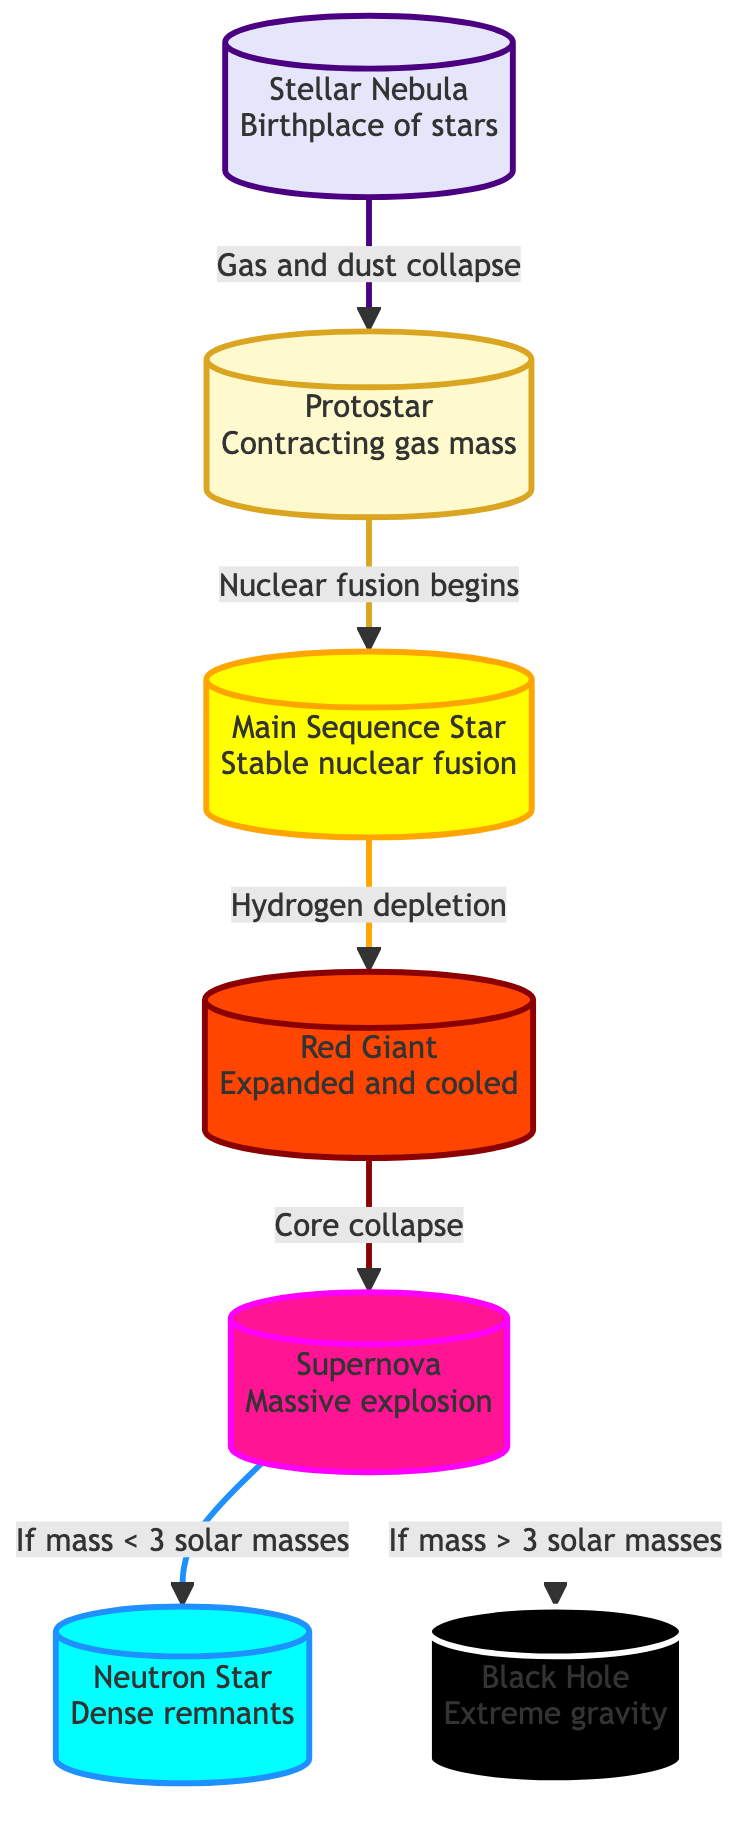What is the first stage of a star's lifecycle? The diagram indicates that the first stage is the "Stellar Nebula," which is identified at the top of the flowchart.
Answer: Stellar Nebula How many stages are shown in the star lifecycle? By counting the nodes in the diagram, we identify a total of 7 distinct stages: Stellar Nebula, Protostar, Main Sequence Star, Red Giant, Supernova, Neutron Star, and Black Hole.
Answer: 7 What connects the protostar and the main sequence star? The diagram shows the connection between these two stages, labeled as "Nuclear fusion begins," indicating the key event that transitions the protostar to the main sequence star.
Answer: Nuclear fusion begins What happens to a star when it exhausts hydrogen? The flow from the main sequence star points to the red giant stage labeled "Hydrogen depletion," indicating that this is the consequence of exhausting hydrogen.
Answer: Hydrogen depletion What is the result if a star has a mass greater than 3 solar masses during a supernova event? The diagram specifies that if the mass is greater than 3 solar masses, the star will result in a "Black Hole," following the flow from the supernova node.
Answer: Black Hole What precedes a supernova in a star's lifecycle? The direct flow in the diagram shows that the red giant stage precedes the supernova, marked by the event "Core collapse."
Answer: Red Giant In which stage does a star experience nuclear fusion? According to the diagram, nuclear fusion takes place during the main sequence star phase, as indicated in the description of that stage.
Answer: Main Sequence Star What is the description of the neutron star stage? The neutron star node in the diagram is described as "Dense remnants," which highlights its characteristics following a supernova.
Answer: Dense remnants How does a stellar nebula transform into a protostar? The transformation is indicated in the diagram with the label "Gas and dust collapse," showing the process that leads from the stellar nebula to the protostar phase.
Answer: Gas and dust collapse 